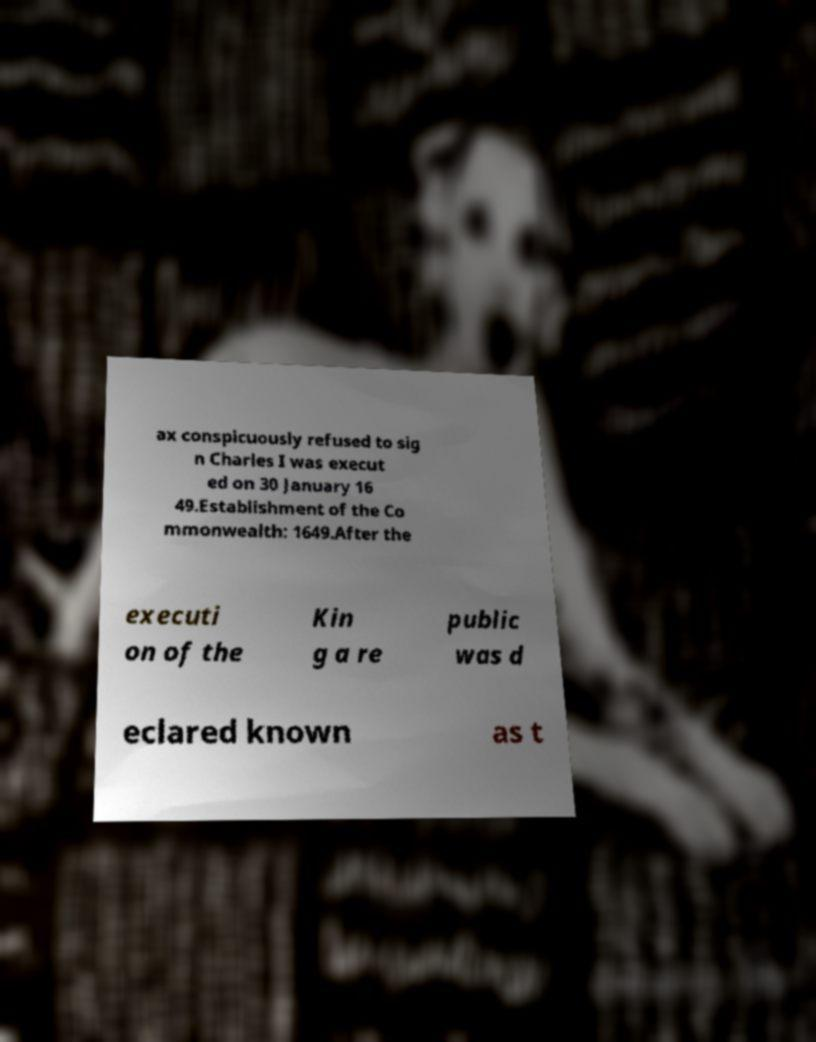Can you read and provide the text displayed in the image?This photo seems to have some interesting text. Can you extract and type it out for me? ax conspicuously refused to sig n Charles I was execut ed on 30 January 16 49.Establishment of the Co mmonwealth: 1649.After the executi on of the Kin g a re public was d eclared known as t 